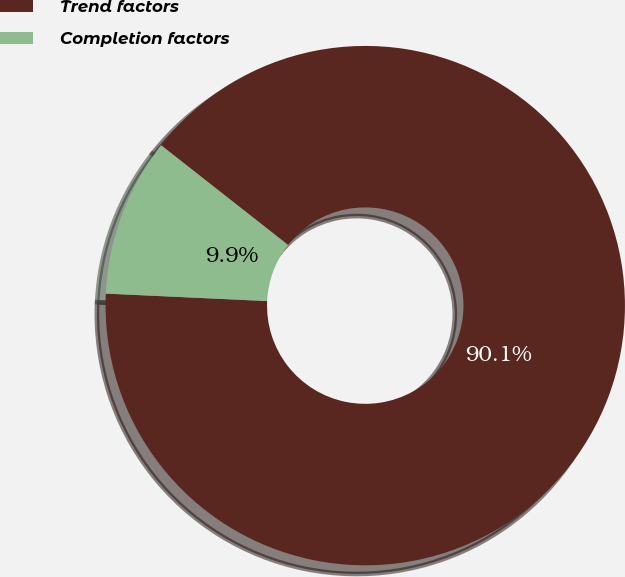Convert chart to OTSL. <chart><loc_0><loc_0><loc_500><loc_500><pie_chart><fcel>Trend factors<fcel>Completion factors<nl><fcel>90.14%<fcel>9.86%<nl></chart> 